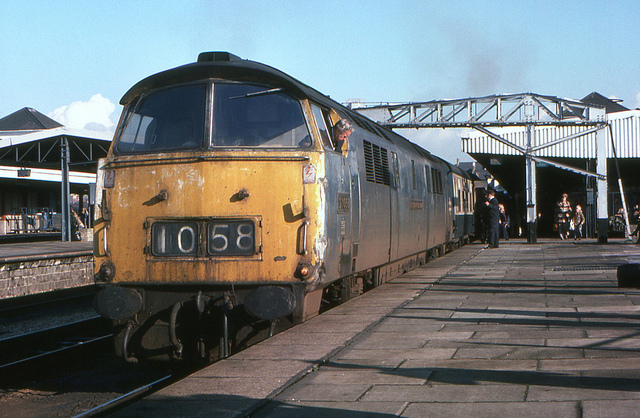Extract all visible text content from this image. 10 58 